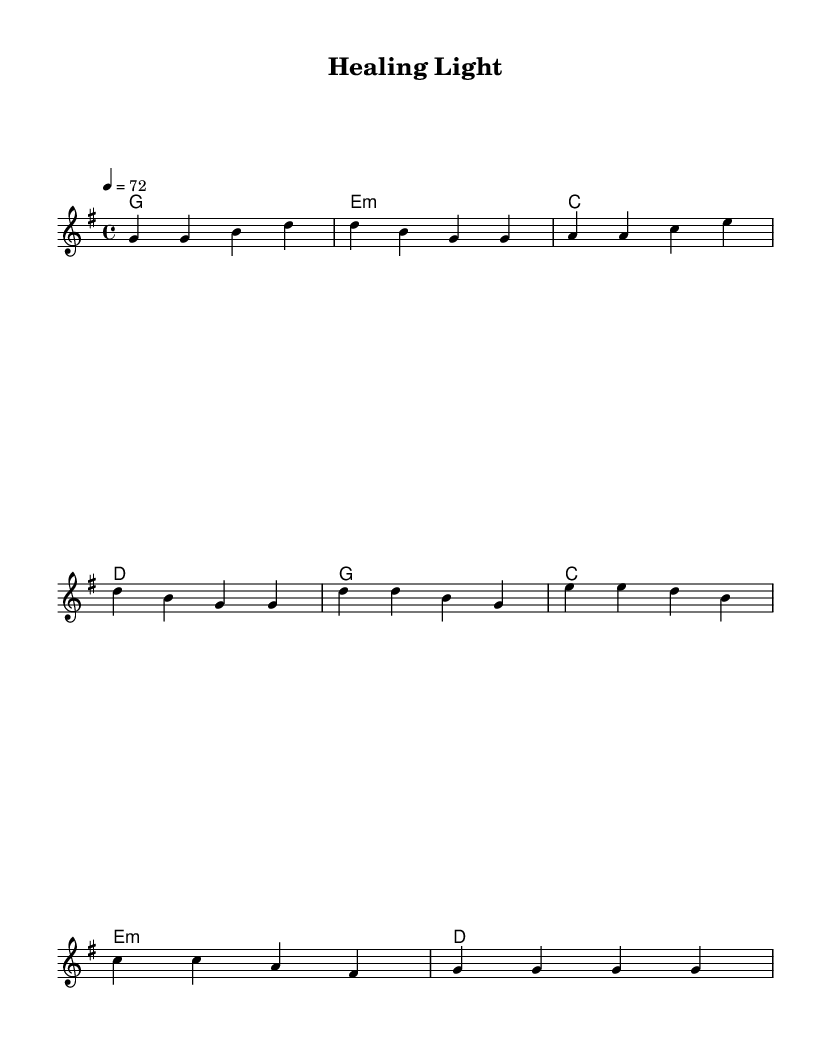What is the key signature of this music? The key signature is G major, which has one sharp (F#).
Answer: G major What is the time signature of this music? The time signature is indicated as 4/4, meaning there are four beats in each measure.
Answer: 4/4 What is the tempo marking given in this piece? The tempo marking is 72 beats per minute, which is indicated by the tempo indication at the beginning of the score.
Answer: 72 How many measures are in the verse section? Counting the measures indicated in the melody line, there are four measures in the verse.
Answer: Four What chords are used in the chorus section? The chords used in the chorus are G, C, E minor, and D, as shown in the harmonies section for that part.
Answer: G, C, E minor, D How do the lyrics in the verse begin? The lyrics in the verse begin with the words "In times of trouble, when hope seems far."
Answer: In times of trouble, when hope seems far What is the main theme of the song's lyrics? The main theme revolves around faith and seeking healing, as expressed in both the verse and chorus.
Answer: Faith and healing 